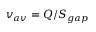Convert formula to latex. <formula><loc_0><loc_0><loc_500><loc_500>v _ { a v } = Q / S _ { g a p }</formula> 